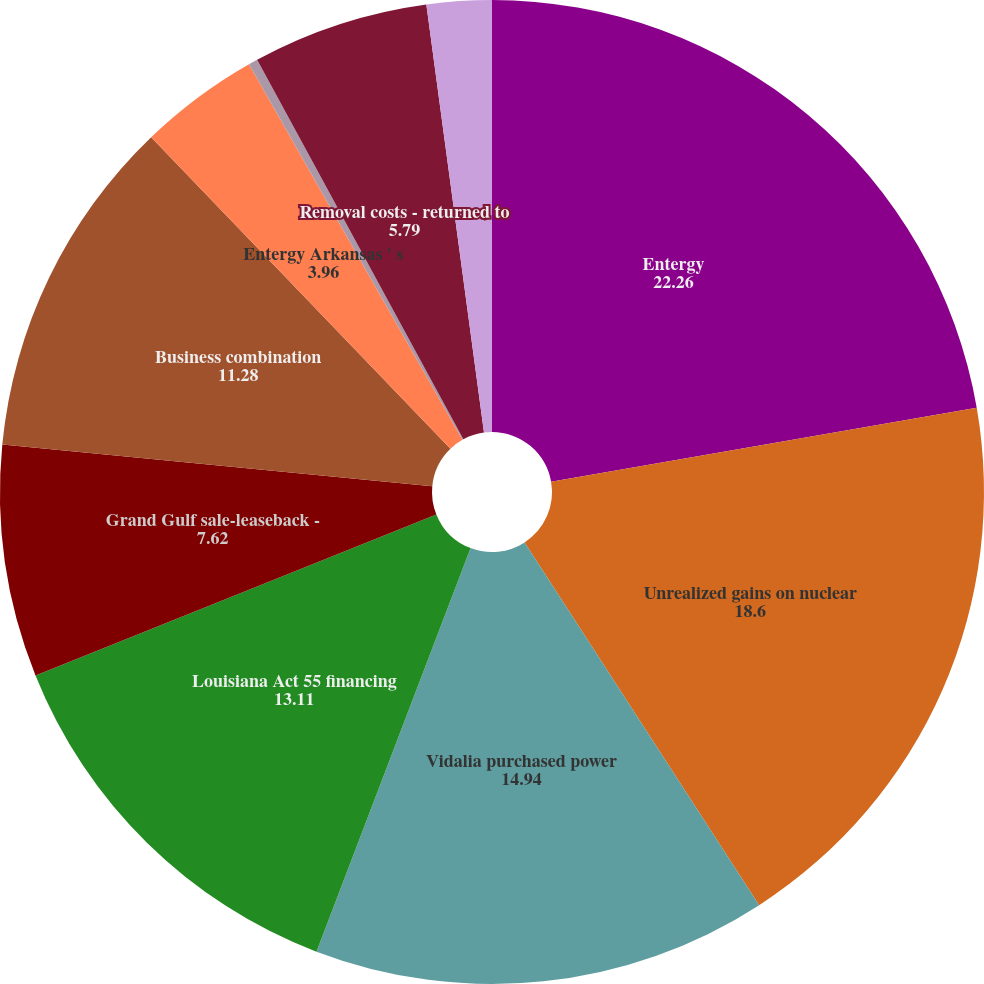Convert chart to OTSL. <chart><loc_0><loc_0><loc_500><loc_500><pie_chart><fcel>Entergy<fcel>Unrealized gains on nuclear<fcel>Vidalia purchased power<fcel>Louisiana Act 55 financing<fcel>Grand Gulf sale-leaseback -<fcel>Business combination<fcel>Entergy Arkansas ' s<fcel>Asset retirement obligation -<fcel>Removal costs - returned to<fcel>Entergy Mississippi ' s<nl><fcel>22.26%<fcel>18.6%<fcel>14.94%<fcel>13.11%<fcel>7.62%<fcel>11.28%<fcel>3.96%<fcel>0.3%<fcel>5.79%<fcel>2.13%<nl></chart> 